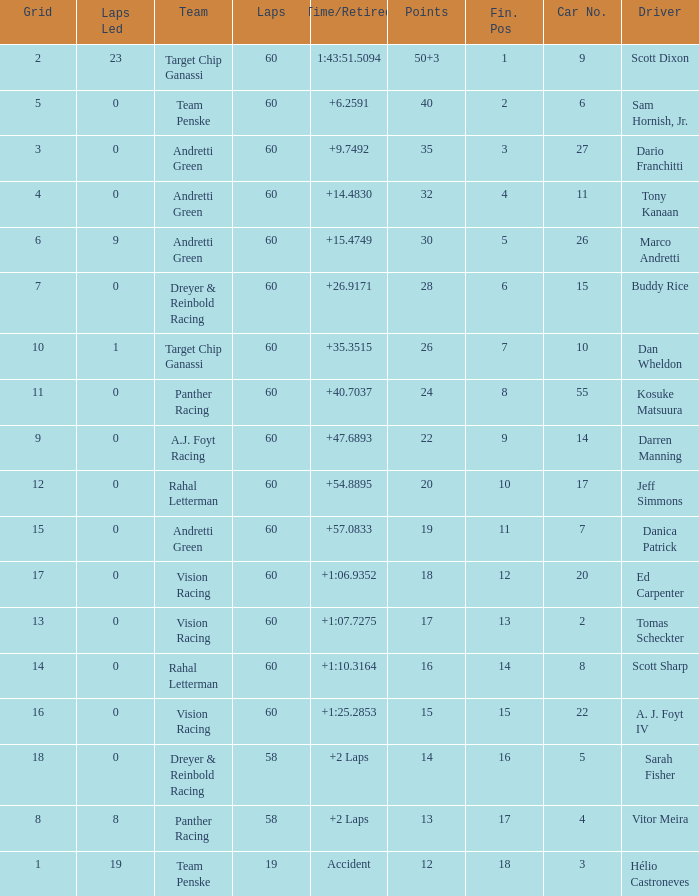I'm looking to parse the entire table for insights. Could you assist me with that? {'header': ['Grid', 'Laps Led', 'Team', 'Laps', 'Time/Retired', 'Points', 'Fin. Pos', 'Car No.', 'Driver'], 'rows': [['2', '23', 'Target Chip Ganassi', '60', '1:43:51.5094', '50+3', '1', '9', 'Scott Dixon'], ['5', '0', 'Team Penske', '60', '+6.2591', '40', '2', '6', 'Sam Hornish, Jr.'], ['3', '0', 'Andretti Green', '60', '+9.7492', '35', '3', '27', 'Dario Franchitti'], ['4', '0', 'Andretti Green', '60', '+14.4830', '32', '4', '11', 'Tony Kanaan'], ['6', '9', 'Andretti Green', '60', '+15.4749', '30', '5', '26', 'Marco Andretti'], ['7', '0', 'Dreyer & Reinbold Racing', '60', '+26.9171', '28', '6', '15', 'Buddy Rice'], ['10', '1', 'Target Chip Ganassi', '60', '+35.3515', '26', '7', '10', 'Dan Wheldon'], ['11', '0', 'Panther Racing', '60', '+40.7037', '24', '8', '55', 'Kosuke Matsuura'], ['9', '0', 'A.J. Foyt Racing', '60', '+47.6893', '22', '9', '14', 'Darren Manning'], ['12', '0', 'Rahal Letterman', '60', '+54.8895', '20', '10', '17', 'Jeff Simmons'], ['15', '0', 'Andretti Green', '60', '+57.0833', '19', '11', '7', 'Danica Patrick'], ['17', '0', 'Vision Racing', '60', '+1:06.9352', '18', '12', '20', 'Ed Carpenter'], ['13', '0', 'Vision Racing', '60', '+1:07.7275', '17', '13', '2', 'Tomas Scheckter'], ['14', '0', 'Rahal Letterman', '60', '+1:10.3164', '16', '14', '8', 'Scott Sharp'], ['16', '0', 'Vision Racing', '60', '+1:25.2853', '15', '15', '22', 'A. J. Foyt IV'], ['18', '0', 'Dreyer & Reinbold Racing', '58', '+2 Laps', '14', '16', '5', 'Sarah Fisher'], ['8', '8', 'Panther Racing', '58', '+2 Laps', '13', '17', '4', 'Vitor Meira'], ['1', '19', 'Team Penske', '19', 'Accident', '12', '18', '3', 'Hélio Castroneves']]} Which team does scott dixon belong to? Target Chip Ganassi. 